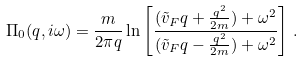<formula> <loc_0><loc_0><loc_500><loc_500>\Pi _ { 0 } ( q , i \omega ) = \frac { m } { 2 \pi q } \ln \left [ \frac { ( \tilde { v } _ { F } q + \frac { q ^ { 2 } } { 2 m } ) + \omega ^ { 2 } } { ( \tilde { v } _ { F } q - \frac { q ^ { 2 } } { 2 m } ) + \omega ^ { 2 } } \right ] \, .</formula> 